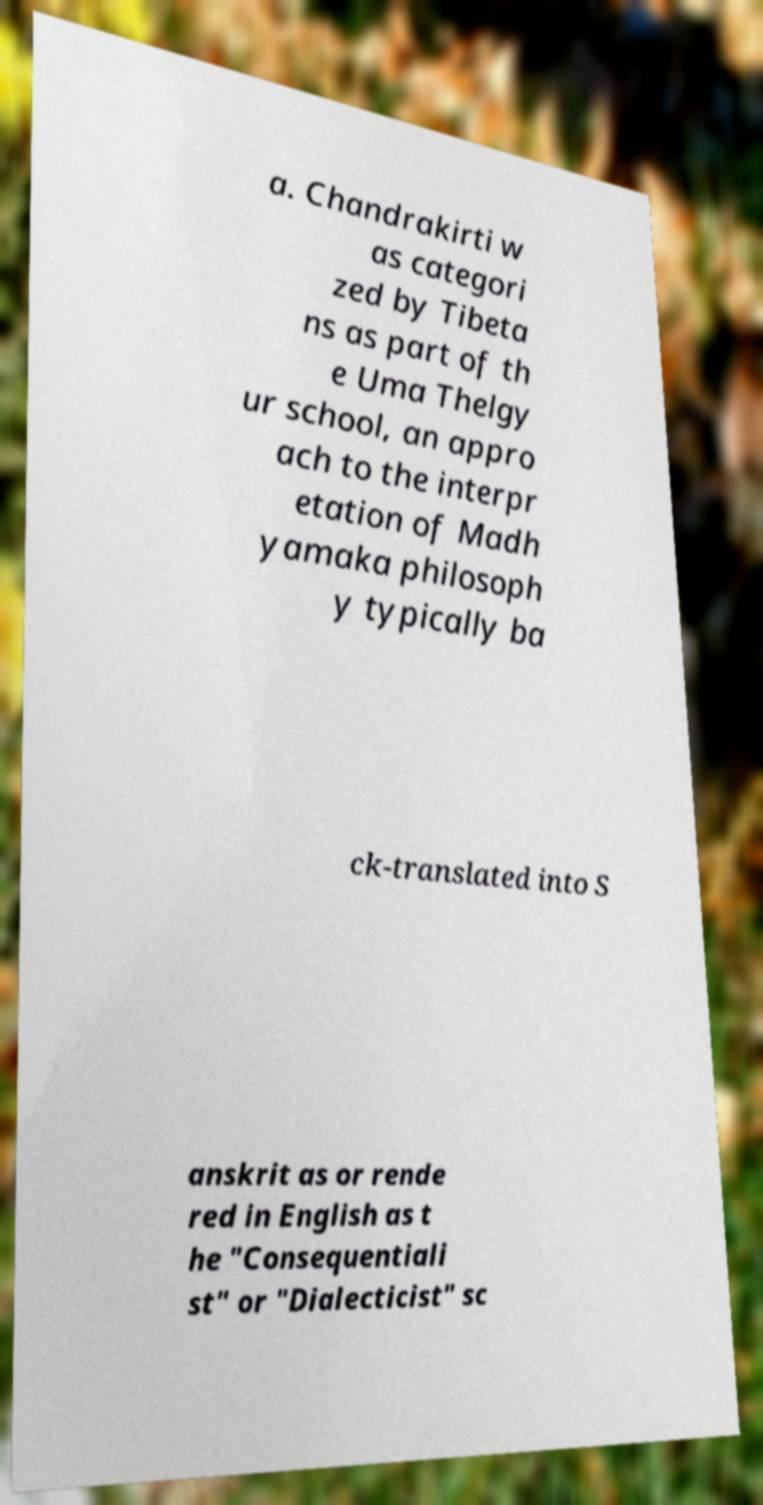Please read and relay the text visible in this image. What does it say? a. Chandrakirti w as categori zed by Tibeta ns as part of th e Uma Thelgy ur school, an appro ach to the interpr etation of Madh yamaka philosoph y typically ba ck-translated into S anskrit as or rende red in English as t he "Consequentiali st" or "Dialecticist" sc 